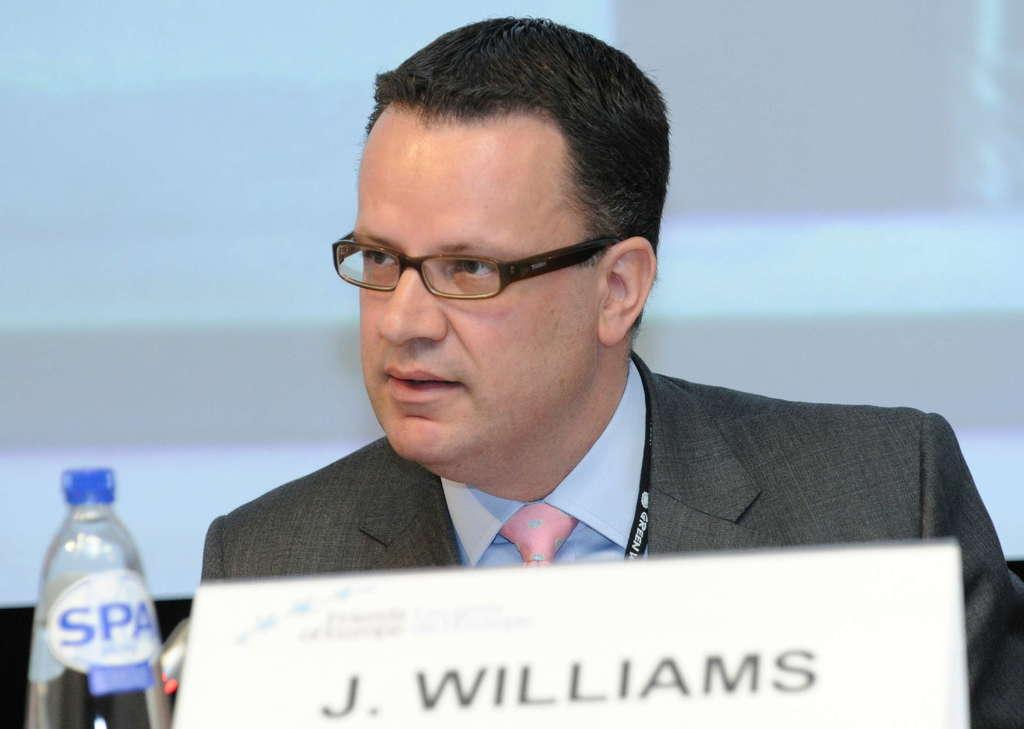Who is the main subject in the picture? There is a person in the picture. What object is in front of the person? There is a bottle in front of the person. What is located beside the bottle? There is a name card beside the bottle. What information is written on the name card? The name card has the words "j. williams" on it. What type of button is being pushed by the person in the image? There is no button present in the image, and the person is not shown pushing anything. What kind of art is displayed on the wall behind the person? The image does not show any art on the wall behind the person. 